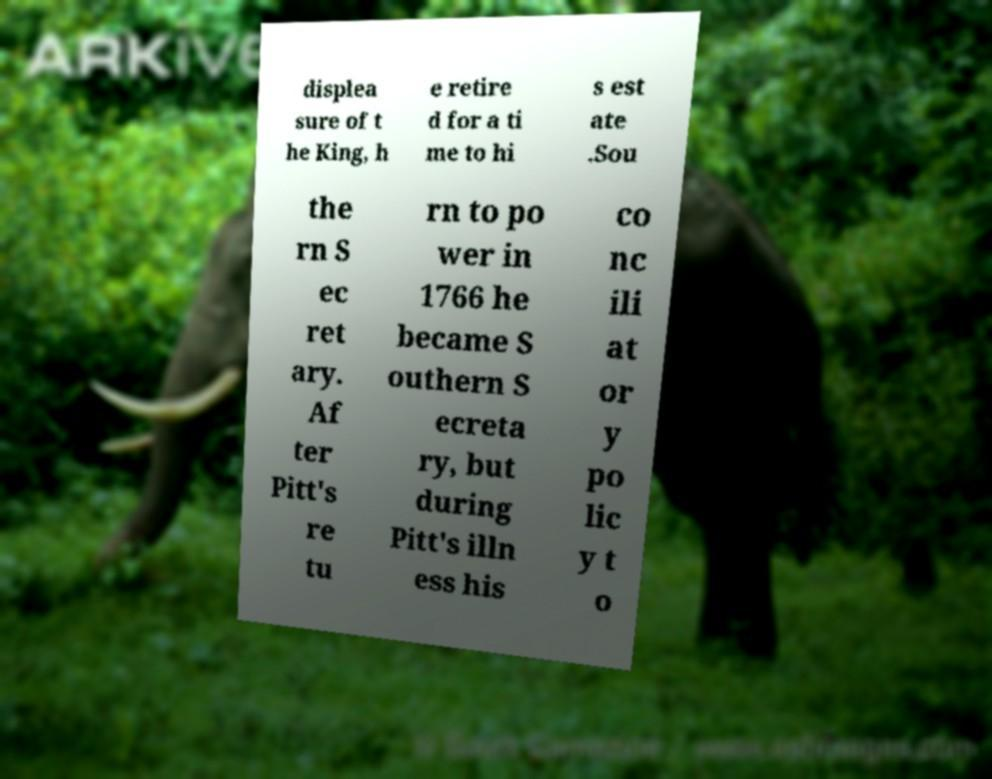Please read and relay the text visible in this image. What does it say? displea sure of t he King, h e retire d for a ti me to hi s est ate .Sou the rn S ec ret ary. Af ter Pitt's re tu rn to po wer in 1766 he became S outhern S ecreta ry, but during Pitt's illn ess his co nc ili at or y po lic y t o 